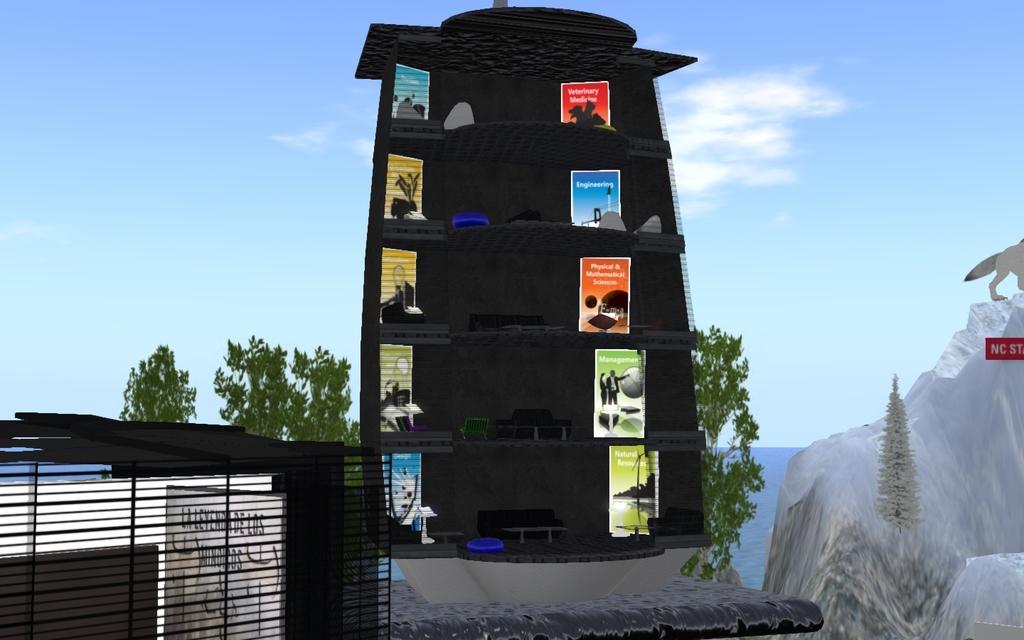Could you give a brief overview of what you see in this image? This looks like an animated image. This is a five story building with posters, couches, lamps and few other things in it. I think this is an iceberg. These are the trees. This looks like an iron grill. Here is the water flowing. At the right side of the image, I can see an animal standing on the iceberg. These are the clouds in the sky. 